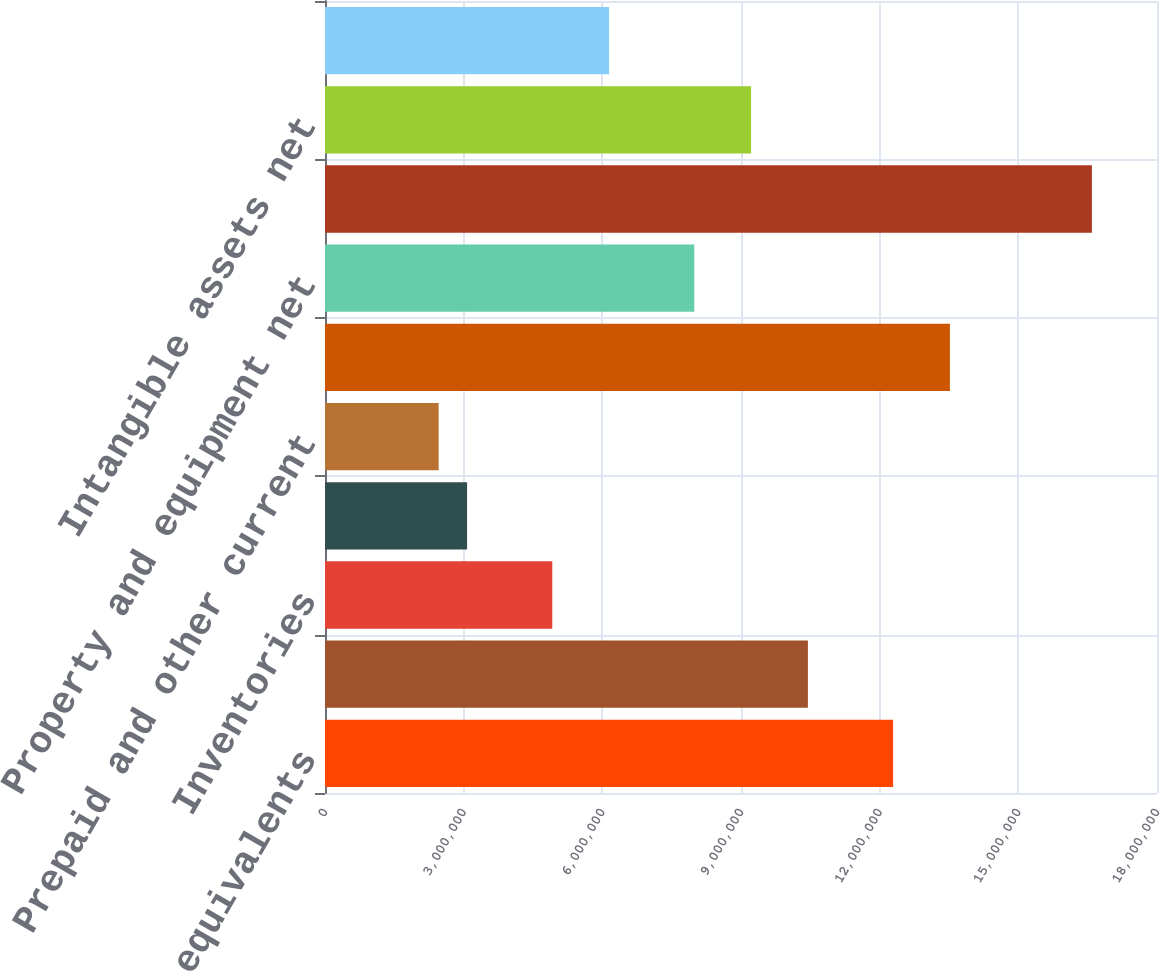Convert chart. <chart><loc_0><loc_0><loc_500><loc_500><bar_chart><fcel>Cash and cash equivalents<fcel>Accounts receivable net of<fcel>Inventories<fcel>Income taxes receivable and<fcel>Prepaid and other current<fcel>Total current assets<fcel>Property and equipment net<fcel>Goodwill<fcel>Intangible assets net<fcel>Long-term prepaid taxes<nl><fcel>1.22905e+07<fcel>1.04471e+07<fcel>4.91708e+06<fcel>3.07373e+06<fcel>2.45929e+06<fcel>1.35194e+07<fcel>7.98932e+06<fcel>1.65916e+07<fcel>9.21821e+06<fcel>6.14597e+06<nl></chart> 